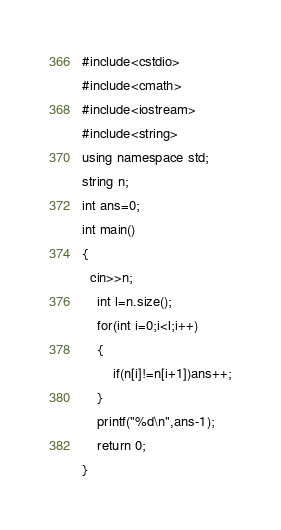<code> <loc_0><loc_0><loc_500><loc_500><_C++_>#include<cstdio>
#include<cmath>
#include<iostream>
#include<string>
using namespace std;
string n;
int ans=0;
int main()
{
  cin>>n;
    int l=n.size();
    for(int i=0;i<l;i++)
    {
        if(n[i]!=n[i+1])ans++;
    }
    printf("%d\n",ans-1);
    return 0;
}</code> 